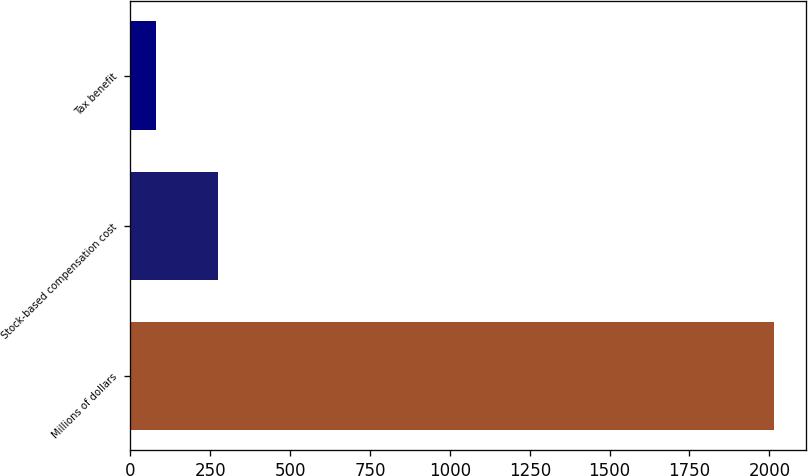Convert chart. <chart><loc_0><loc_0><loc_500><loc_500><bar_chart><fcel>Millions of dollars<fcel>Stock-based compensation cost<fcel>Tax benefit<nl><fcel>2013<fcel>274.2<fcel>81<nl></chart> 